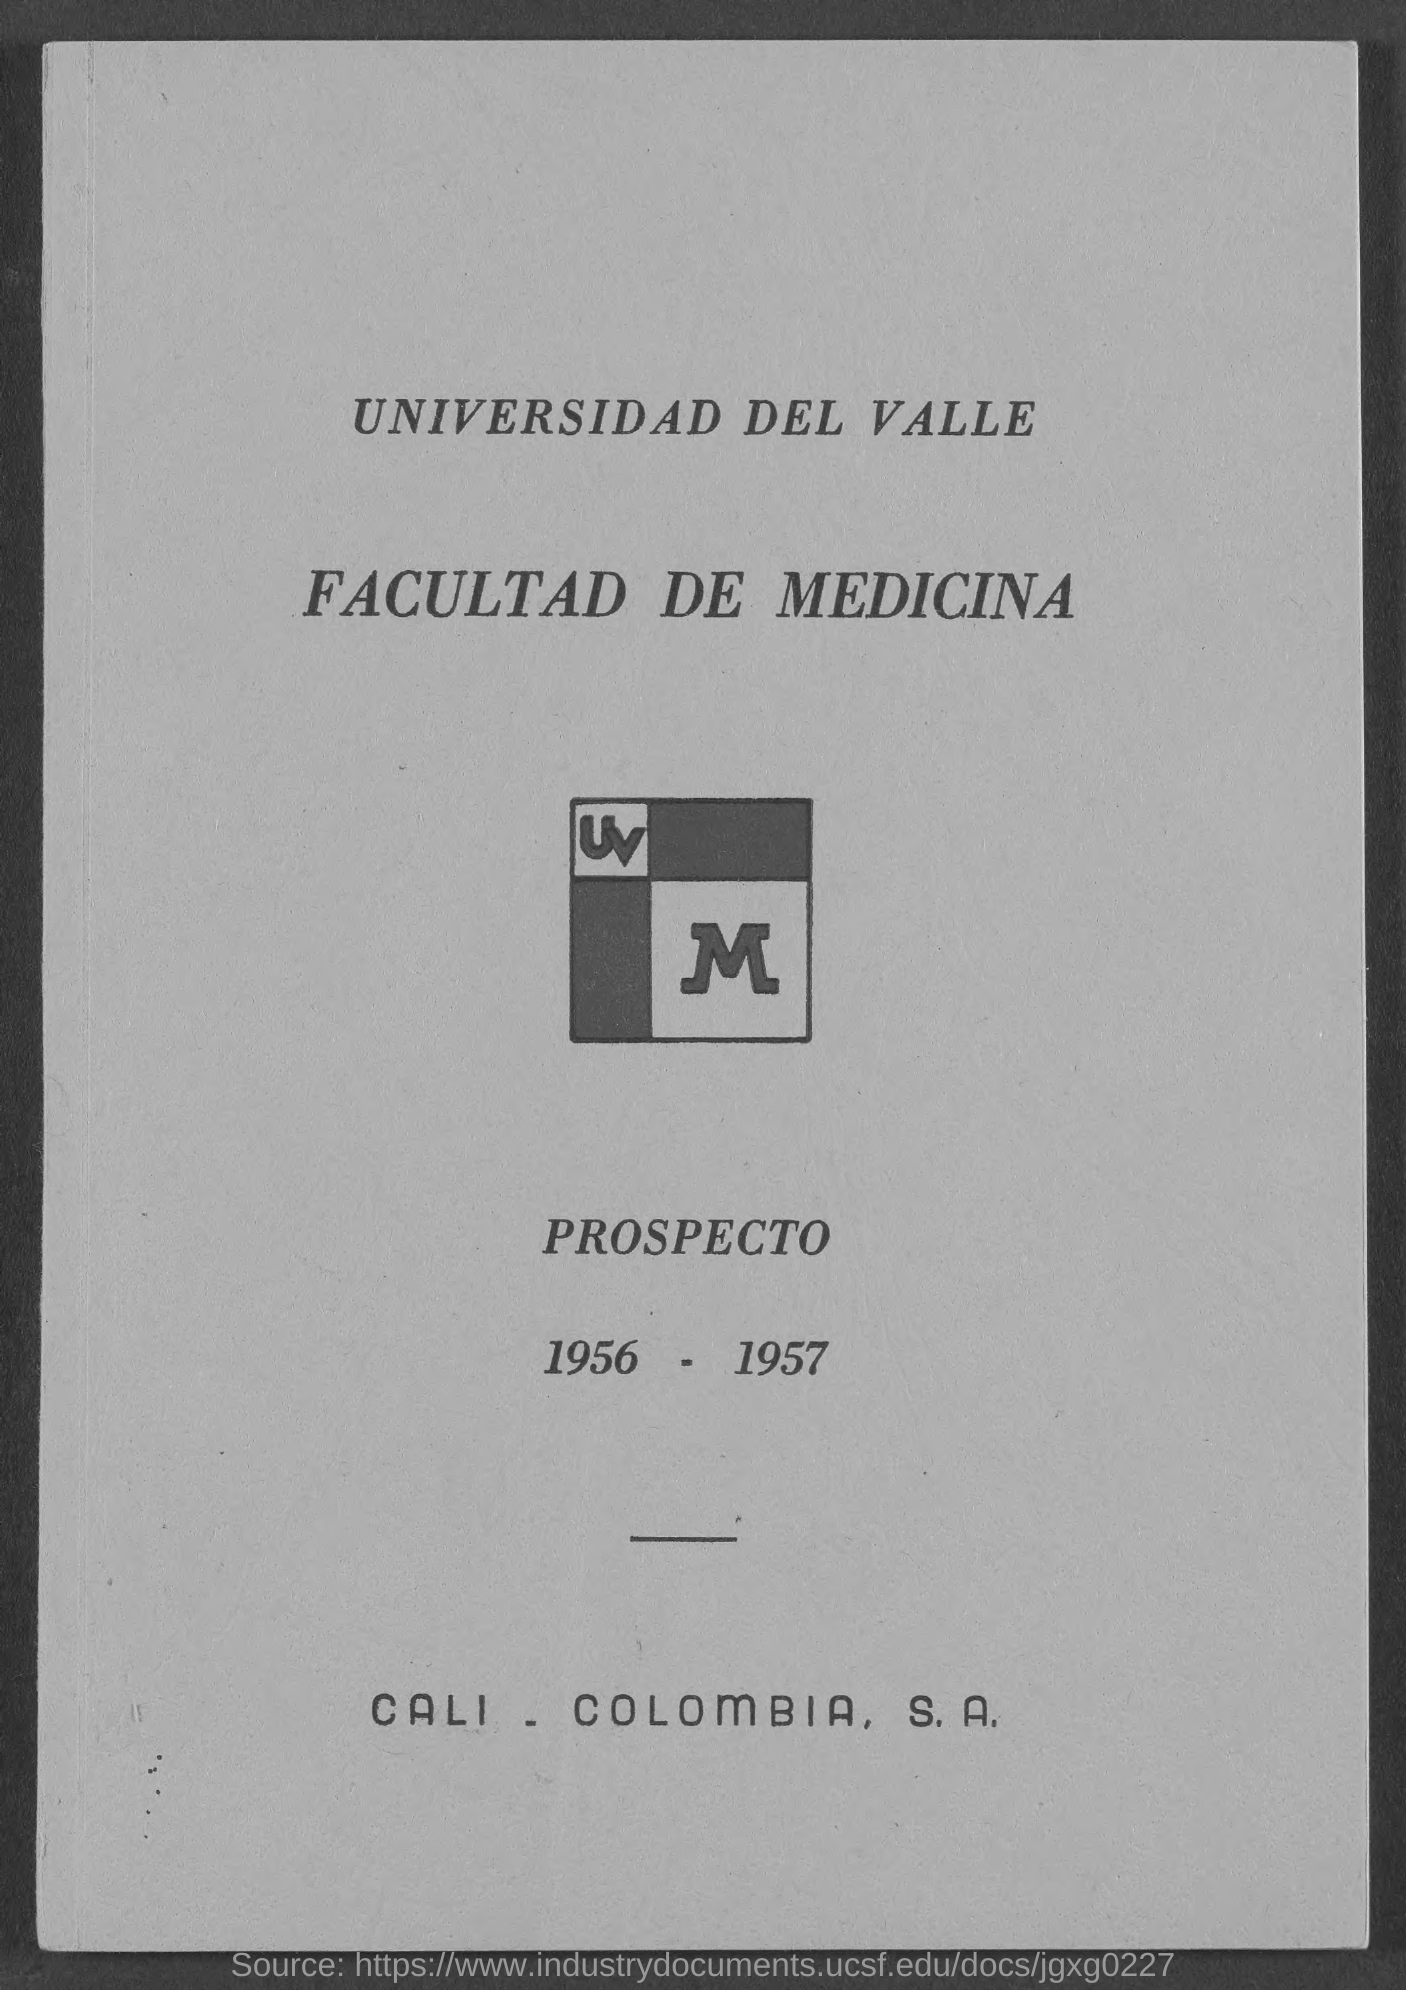Indicate a few pertinent items in this graphic. The duration of the year mentioned here is from 1956 to 1957. 